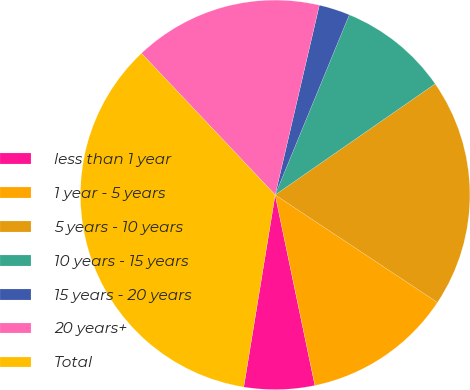Convert chart. <chart><loc_0><loc_0><loc_500><loc_500><pie_chart><fcel>less than 1 year<fcel>1 year - 5 years<fcel>5 years - 10 years<fcel>10 years - 15 years<fcel>15 years - 20 years<fcel>20 years+<fcel>Total<nl><fcel>5.85%<fcel>12.41%<fcel>18.97%<fcel>9.13%<fcel>2.57%<fcel>15.69%<fcel>35.37%<nl></chart> 